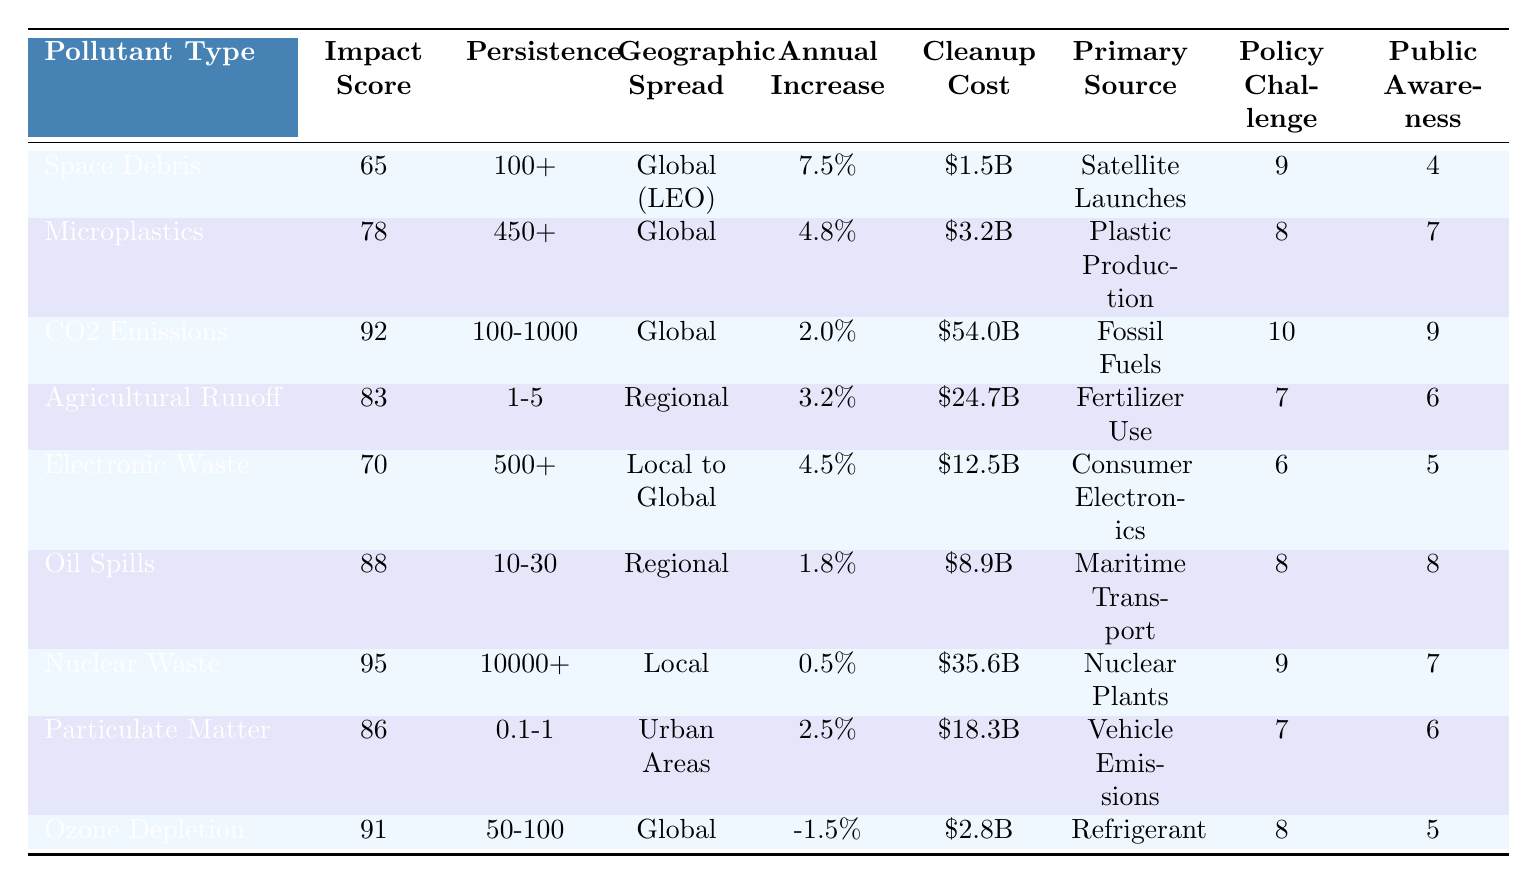What is the Environmental Impact Score for Space Debris? The score for Space Debris is directly listed in the table under "Environmental Impact Score," which shows a value of 65.
Answer: 65 Which pollutant has the highest cleanup cost? By scanning the "Cleanup Cost" column, CO2 Emissions has the highest value listed at \$54.0 billion per year.
Answer: CO2 Emissions Is the geographic spread of Nuclear Waste local or global? The table states that Nuclear Waste has a geographic spread labeled as "Local," indicating it does not extend globally.
Answer: Local What is the average persistence of pollutants in this table? The persistent values are: 100+, 450+, 100-1000, 1-5, 500+, 10-30, 10000+, 0.1-1, 50-100. To estimate the average, we consider the ranges rather than exact values. The persistent scores suggest significant variation, but the average spans decades. We can approximate it, but for clarity, a numerical average isn't straightforward.
Answer: Not easily quantifiable Which pollutant has a Public Awareness Index of 5? "Electronic Waste" and "Ozone Depletion Substances" both have a Public Awareness Index of 5, as seen when checking that column.
Answer: Electronic Waste and Ozone Depletion Substances If we compare the Policy Challenge Scores of Space Debris and Agricultural Runoff, which has a higher score? Space Debris has a score of 9, while Agricultural Runoff has a score of 7. Comparing these two numbers directly shows Space Debris has the higher score.
Answer: Space Debris What is the total cleanup cost for all pollutants combined? Summing the cleanup costs: 1.5 + 3.2 + 54.0 + 24.7 + 12.5 + 8.9 + 35.6 + 18.3 + 2.8 gives a total of 141.5 billion USD per year.
Answer: 141.5 billion USD Which pollutant type has the lowest Annual Increase Rate? The column for "Annual Increase Rate" indicates that Nuclear Waste, with a rate of 0.5%, is the lowest when compared to other values in that column.
Answer: Nuclear Waste True or False: Agricultural Runoff has a greater Environmental Impact Score than Microplastics. Agricultural Runoff has a score of 83, which is greater than Microplastics with a score of 78, making the statement true.
Answer: True If you were to rank pollutants based on descending impact scores, which would be in the third position? By sorting the Environmental Impact Scores from highest to lowest, the order is: CO2 Emissions (92), Nuclear Waste (95), and Ozone Depletion Substances (91) in third position.
Answer: Ozone Depletion Substances 